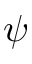Convert formula to latex. <formula><loc_0><loc_0><loc_500><loc_500>\psi</formula> 